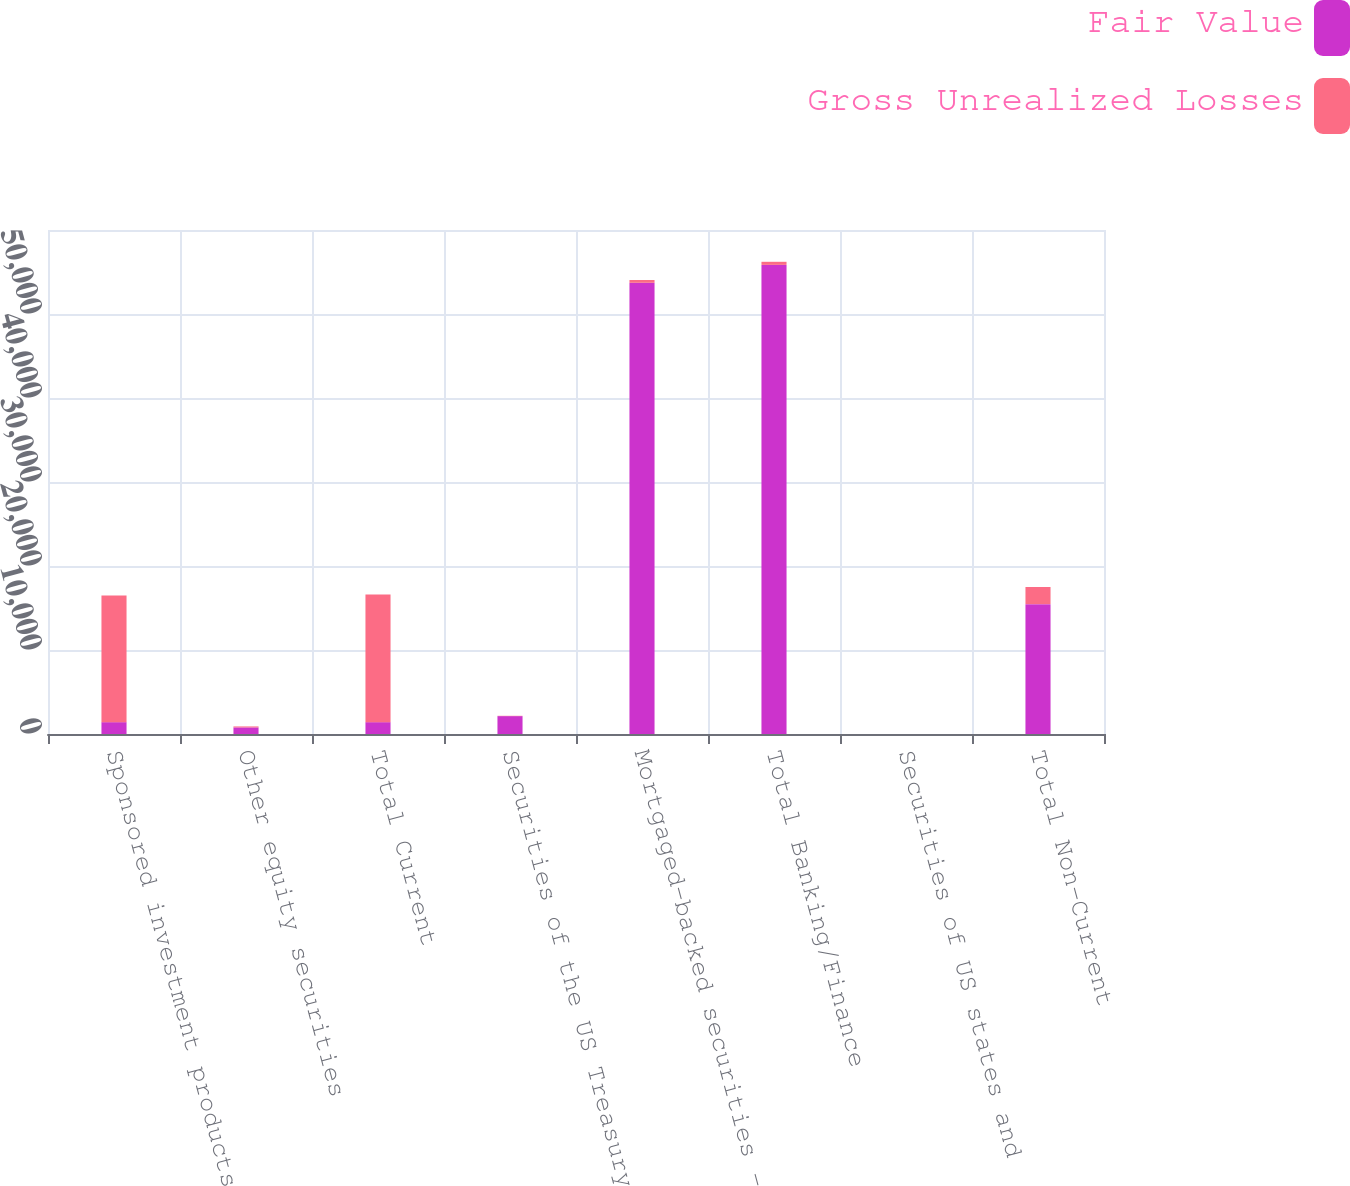Convert chart to OTSL. <chart><loc_0><loc_0><loc_500><loc_500><stacked_bar_chart><ecel><fcel>Sponsored investment products<fcel>Other equity securities<fcel>Total Current<fcel>Securities of the US Treasury<fcel>Mortgaged-backed securities -<fcel>Total Banking/Finance<fcel>Securities of US states and<fcel>Total Non-Current<nl><fcel>Fair Value<fcel>1410<fcel>782<fcel>1410<fcel>2129<fcel>53717<fcel>55846<fcel>0<fcel>15460<nl><fcel>Gross Unrealized Losses<fcel>15082<fcel>118<fcel>15200<fcel>36<fcel>333<fcel>369<fcel>0<fcel>2038<nl></chart> 